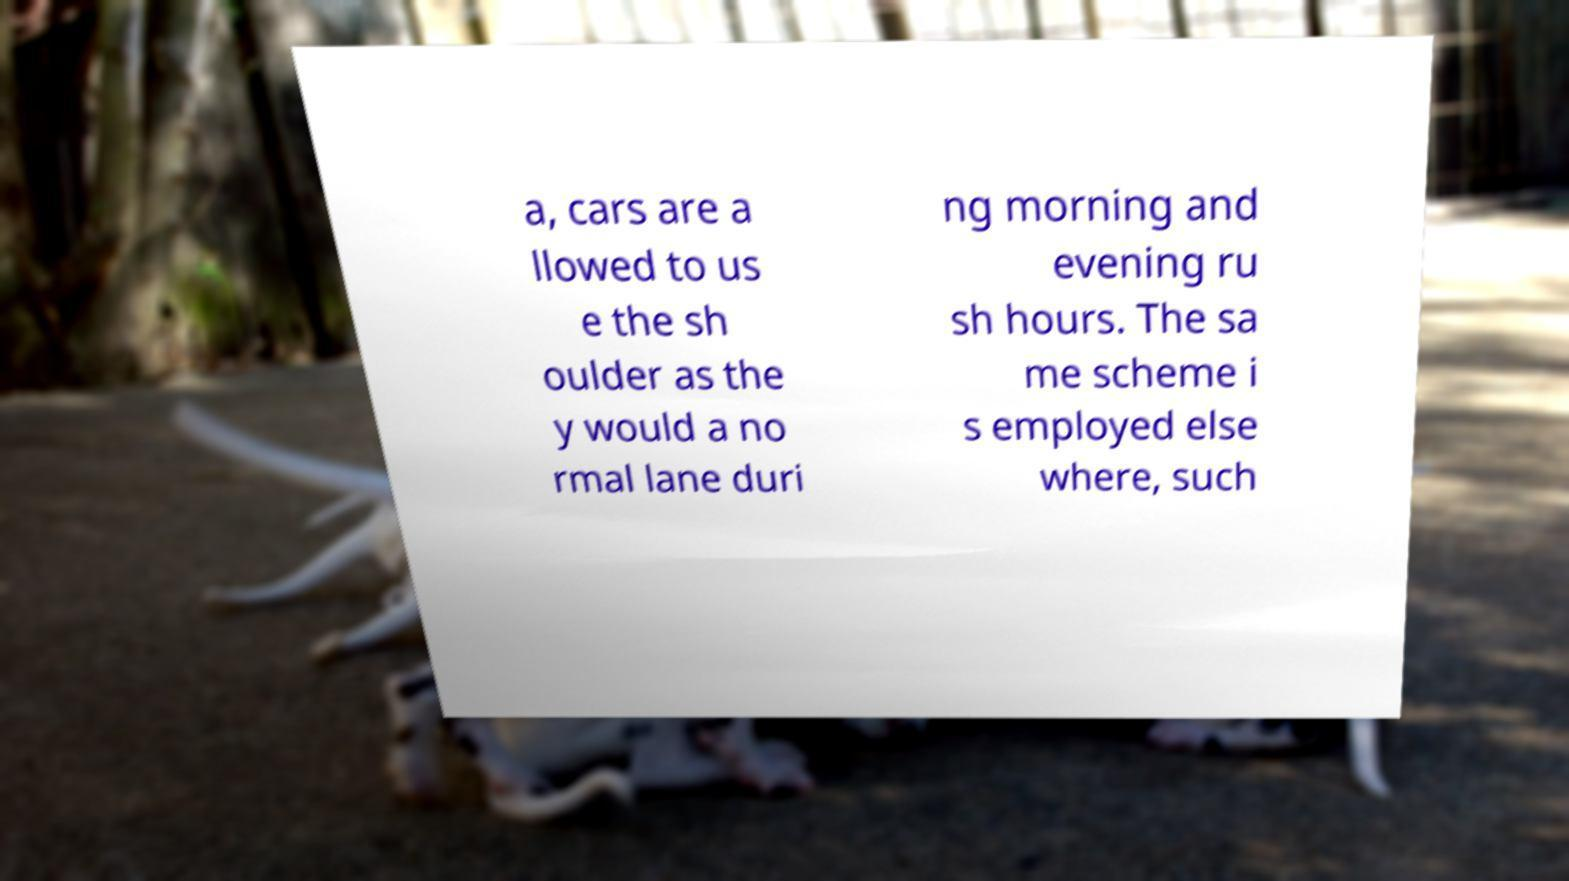I need the written content from this picture converted into text. Can you do that? a, cars are a llowed to us e the sh oulder as the y would a no rmal lane duri ng morning and evening ru sh hours. The sa me scheme i s employed else where, such 